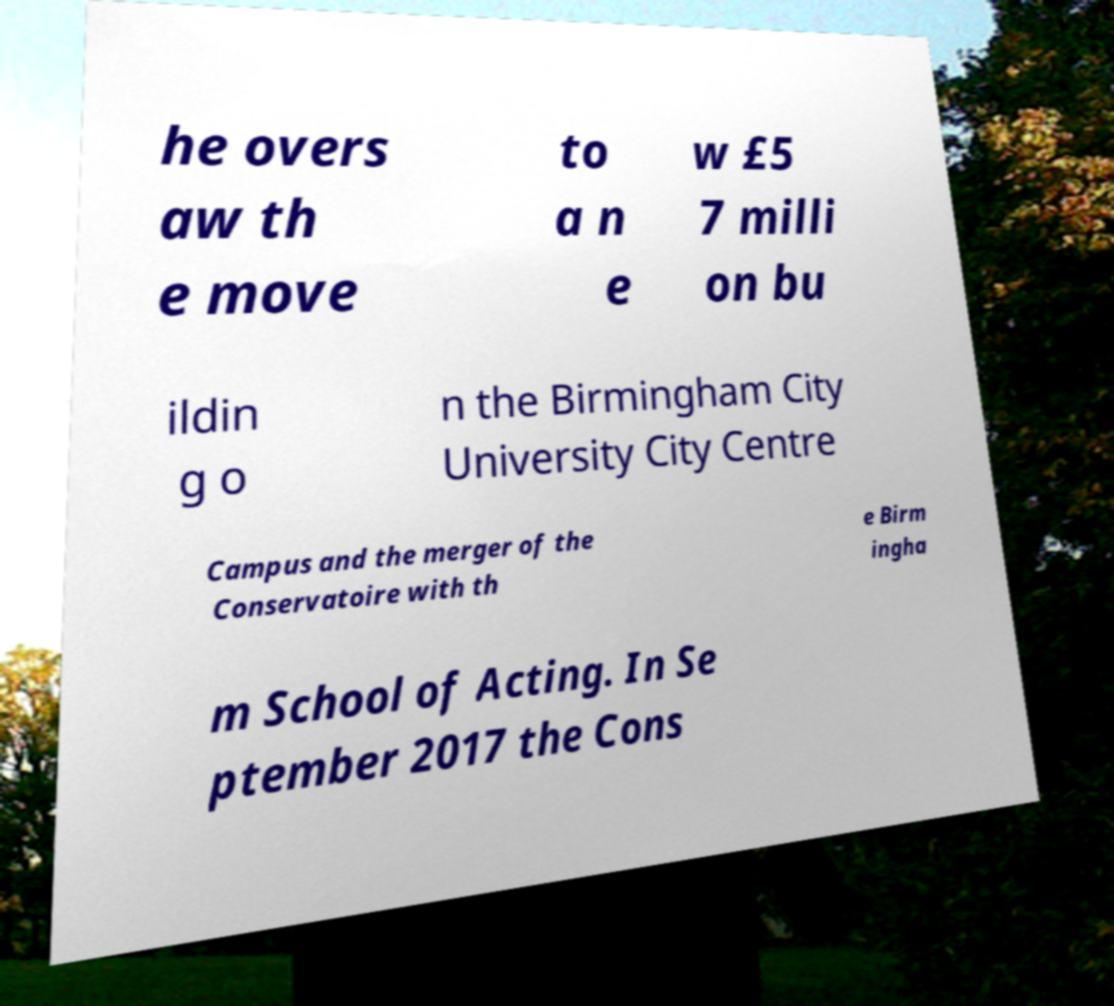I need the written content from this picture converted into text. Can you do that? he overs aw th e move to a n e w £5 7 milli on bu ildin g o n the Birmingham City University City Centre Campus and the merger of the Conservatoire with th e Birm ingha m School of Acting. In Se ptember 2017 the Cons 